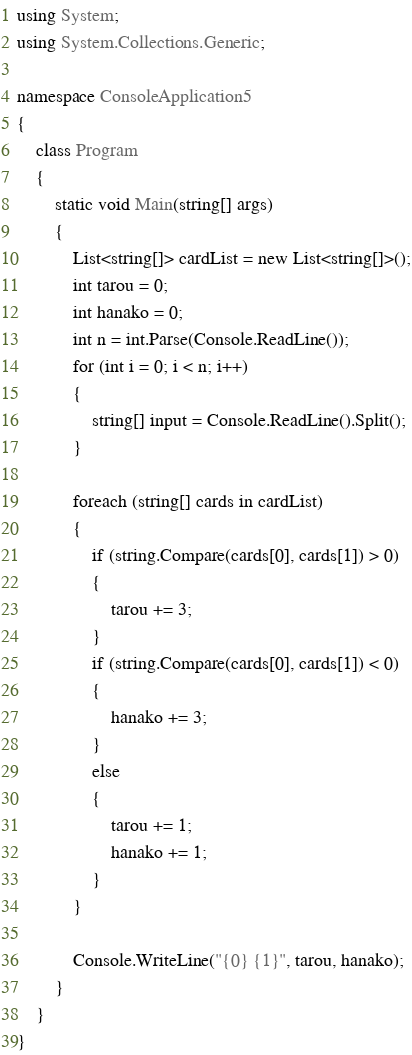Convert code to text. <code><loc_0><loc_0><loc_500><loc_500><_C#_>using System;
using System.Collections.Generic;

namespace ConsoleApplication5
{
    class Program
    {
        static void Main(string[] args)
        {
            List<string[]> cardList = new List<string[]>();
            int tarou = 0;
            int hanako = 0;
            int n = int.Parse(Console.ReadLine());
            for (int i = 0; i < n; i++)
            {
                string[] input = Console.ReadLine().Split();
            }

            foreach (string[] cards in cardList)
            {
                if (string.Compare(cards[0], cards[1]) > 0)
                {
                    tarou += 3;
                }
                if (string.Compare(cards[0], cards[1]) < 0)
                {
                    hanako += 3;
                }
                else
                {
                    tarou += 1;
                    hanako += 1;
                }
            }

            Console.WriteLine("{0} {1}", tarou, hanako);
        }
    }
}</code> 